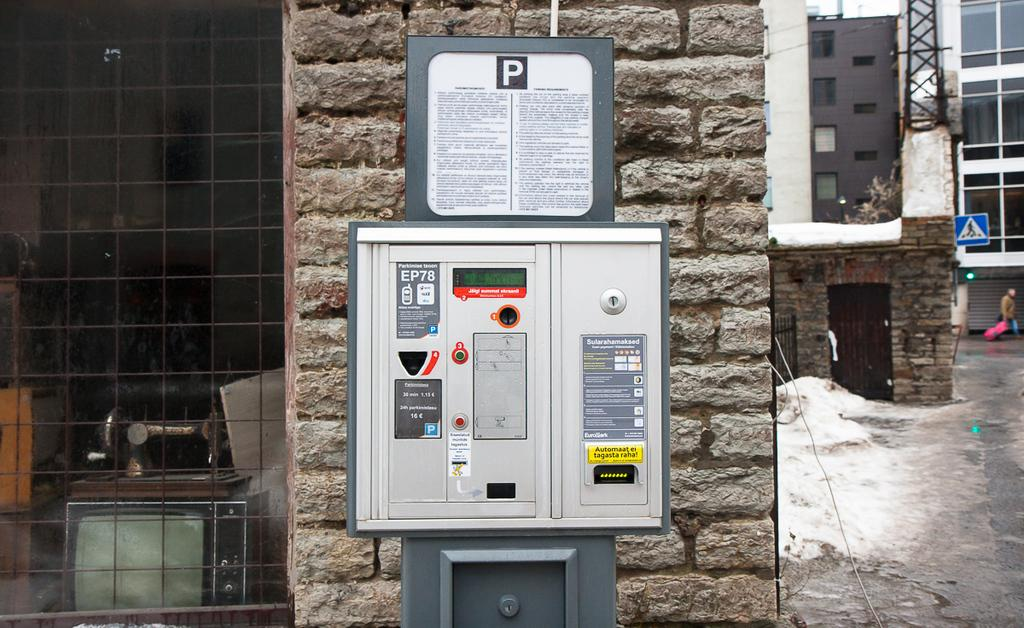<image>
Relay a brief, clear account of the picture shown. A brick column in an urban setting holds a metal electrical box with the letter "P" written across the top. 